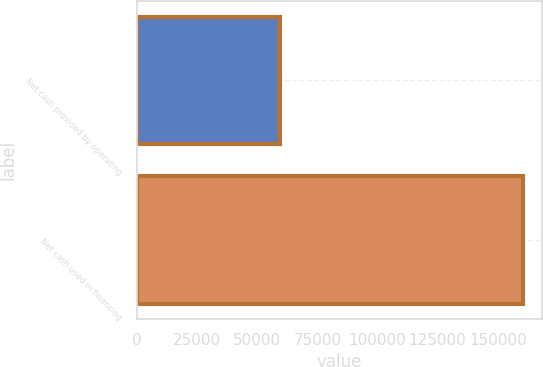Convert chart. <chart><loc_0><loc_0><loc_500><loc_500><bar_chart><fcel>Net cash provided by operating<fcel>Net cash used in financing<nl><fcel>59522<fcel>160520<nl></chart> 